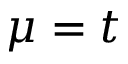<formula> <loc_0><loc_0><loc_500><loc_500>\mu = t</formula> 